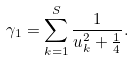<formula> <loc_0><loc_0><loc_500><loc_500>\gamma _ { 1 } = \sum _ { k = 1 } ^ { S } \frac { 1 } { u _ { k } ^ { 2 } + \frac { 1 } { 4 } } .</formula> 